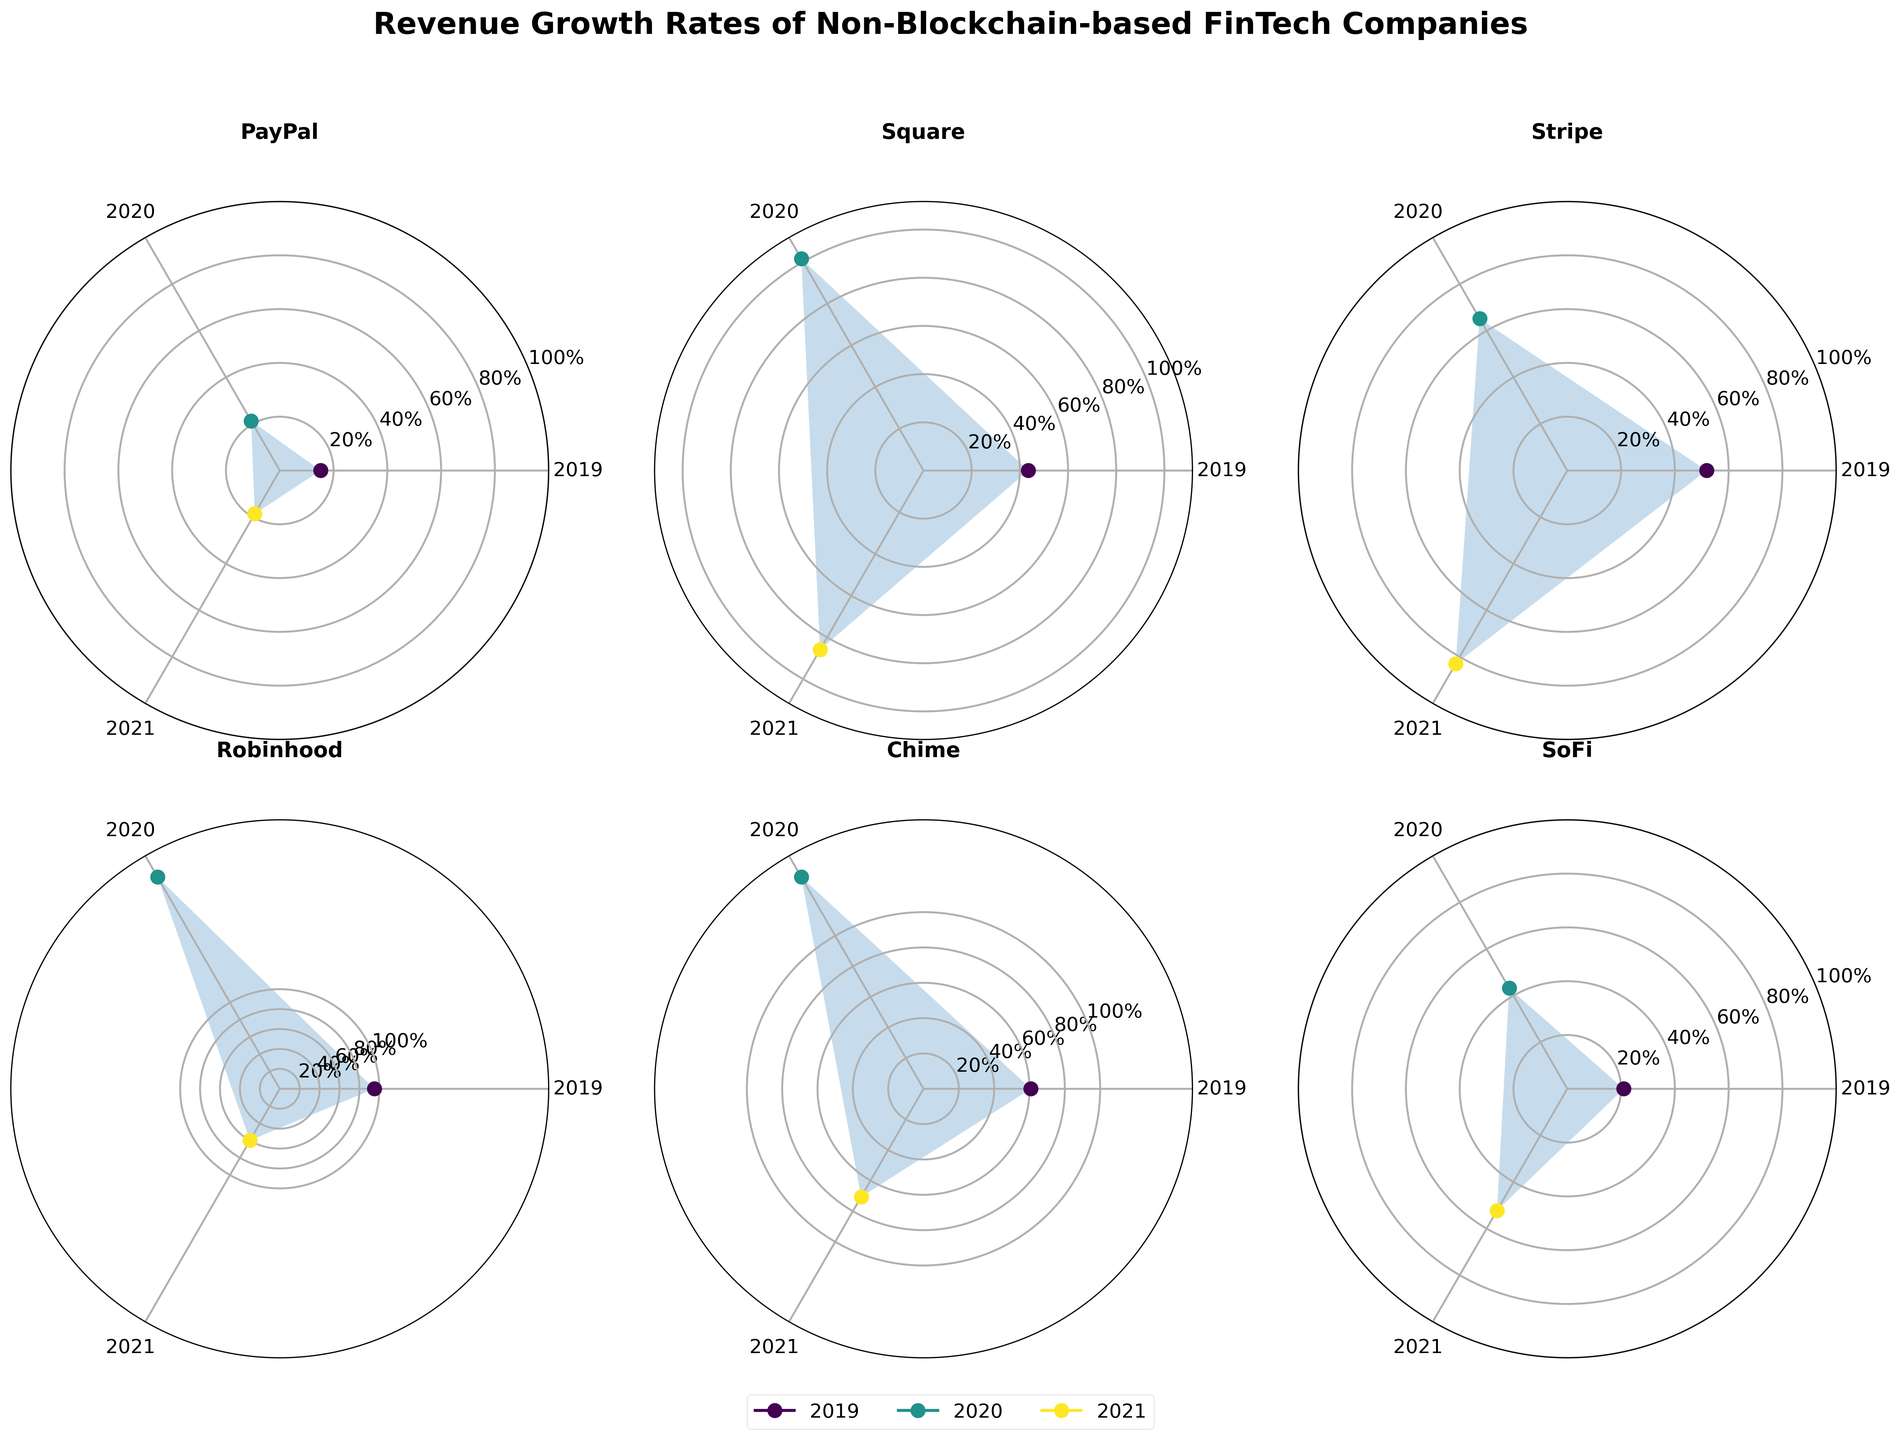What is the title of the figure? The title is usually located at the top of the figure, and in this case, it says "Revenue Growth Rates of Non-Blockchain-based FinTech Companies".
Answer: Revenue Growth Rates of Non-Blockchain-based FinTech Companies Which company had the highest revenue growth rate in 2020? By examining each company's plotted point for 2020 (usually marked by specific colors/labels in the legend), you will see that Robinhood had the highest growth rate for this year.
Answer: Robinhood What is the range of revenue growth rates depicted on the radial axis? The radial axis typically shows numerical values and ticks. Here, it ranges from 0% to 100% with intermediate ticks labeled as 20%, 40%, 60%, and 80%.
Answer: 0% to 100% How did Square's revenue growth rate change from 2019 to 2021? By looking at Square's subplot, you can see the markers corresponding to each year connected by lines. Summarize the values: from 43.5 in 2019, soaring to 101.5 in 2020, then slightly declining to 85.9 in 2021.
Answer: Increased from 43.5% to 101.5%, then decreased to 85.9% Among the companies depicted, which had the largest drop in revenue growth rate from 2020 to 2021? Compare the drops between years 2020 and 2021 by examining each subplot. Robinhood shows the most significant drop from 245.5% to 59.8%.
Answer: Robinhood Rank the companies based on their average revenue growth rate over the three years. Calculate the average growth rate for each company over the three years, then rank them: Robinhood (133.43), Chime (89.93), Stripe (66.67), Square (76.97), SoFi (38.83), PayPal (18.37).
Answer: Robinhood, Chime, Stripe, Square, SoFi, PayPal What pattern is visible if we compare Chime's 2019, 2020, and 2021 growth rates on the polar chart? Observing Chime's polar plot, there is a sharp increase from 60.8% to 138.4% from 2019 to 2020, followed by a decrease to 70.6% in 2021.
Answer: Increase then decrease Which company maintained the most consistent revenue growth rate over the three years? By looking for minimal fluctuations in the plotted points and filled areas, PayPal exhibits the steadiest growth from 15.2% to 21.3%, then to 18.6%.
Answer: PayPal 